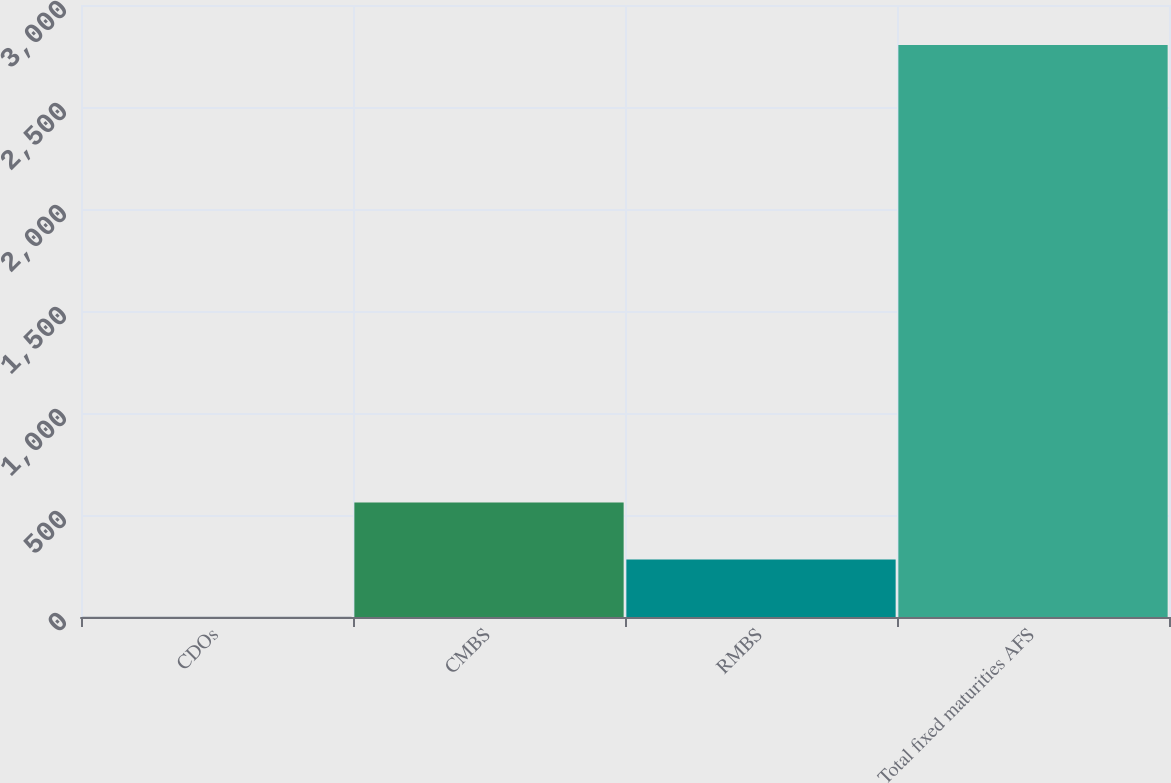Convert chart. <chart><loc_0><loc_0><loc_500><loc_500><bar_chart><fcel>CDOs<fcel>CMBS<fcel>RMBS<fcel>Total fixed maturities AFS<nl><fcel>1<fcel>561.6<fcel>281.3<fcel>2804<nl></chart> 